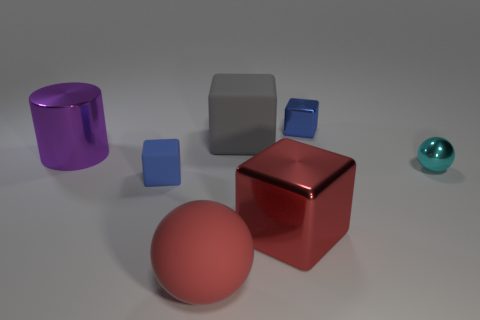If these objects were used in a still life drawing, what feelings might the artist be trying to convey? Given the simplicity and arrangement of the forms, an artist might use these objects in a still life to convey a sense of order and calm. The cool color palette and the clean lines of the shapes might suggest a theme of serenity or minimalism. 